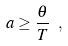Convert formula to latex. <formula><loc_0><loc_0><loc_500><loc_500>a \geq \frac { \theta } { T } \ ,</formula> 